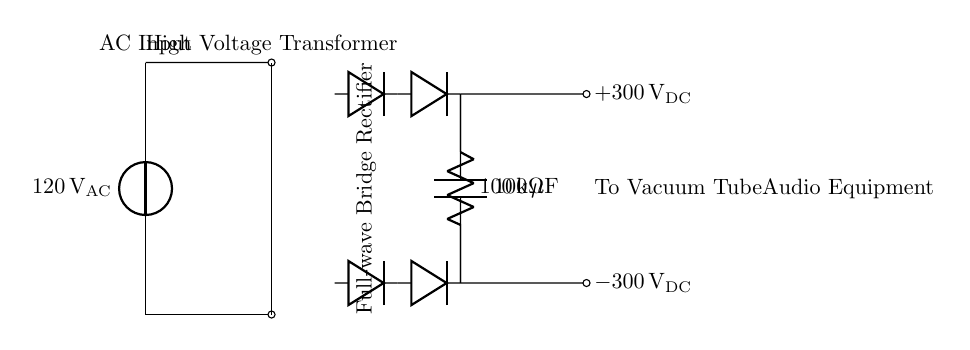What is the input voltage of the circuit? The circuit diagram shows an AC voltage source labeled as 120 volts AC, indicating the input power supply.
Answer: 120 volts AC What is the output voltage of the circuit? The circuit indicates two output voltage levels, with one labeled as plus 300 volts DC and the other as minus 300 volts DC, representing the supply to the vacuum tube equipment.
Answer: Plus 300 volts DC and minus 300 volts DC What type of rectification is used in this circuit? The diagram illustrates a full-wave bridge rectifier configuration, which utilizes four diodes to convert AC to DC over both halves of the waveform.
Answer: Full-wave bridge rectifier What component is used for smoothing in this circuit? A capacitor labeled as 100 microfarads is present in the circuit, designed to smooth out the DC output by reducing voltage fluctuations after rectification.
Answer: 100 microfarads capacitor Why is there a bleeder resistor in the circuit? The bleeder resistor, labeled as 100 kilohms, is included to discharge the capacitor safely when the power is turned off, preventing electric shock and ensuring the capacitor does not retain charge after use.
Answer: To discharge the capacitor What is the purpose of the transformer in this circuit? The transformer is used to step down or step up the voltage from the AC source to a level suitable for the rectification and subsequent use in the audio equipment; in this case, it transforms the input voltage to a higher level.
Answer: To adjust voltage levels What could happen if the output voltage exceeds the rated voltage of the vacuum tubes? If the output voltage exceeds the rated voltage of the vacuum tubes, it may lead to breakdown of the tubes or damage to the audio equipment, resulting in malfunction or reduced lifespan.
Answer: Damage to the vacuum tubes 